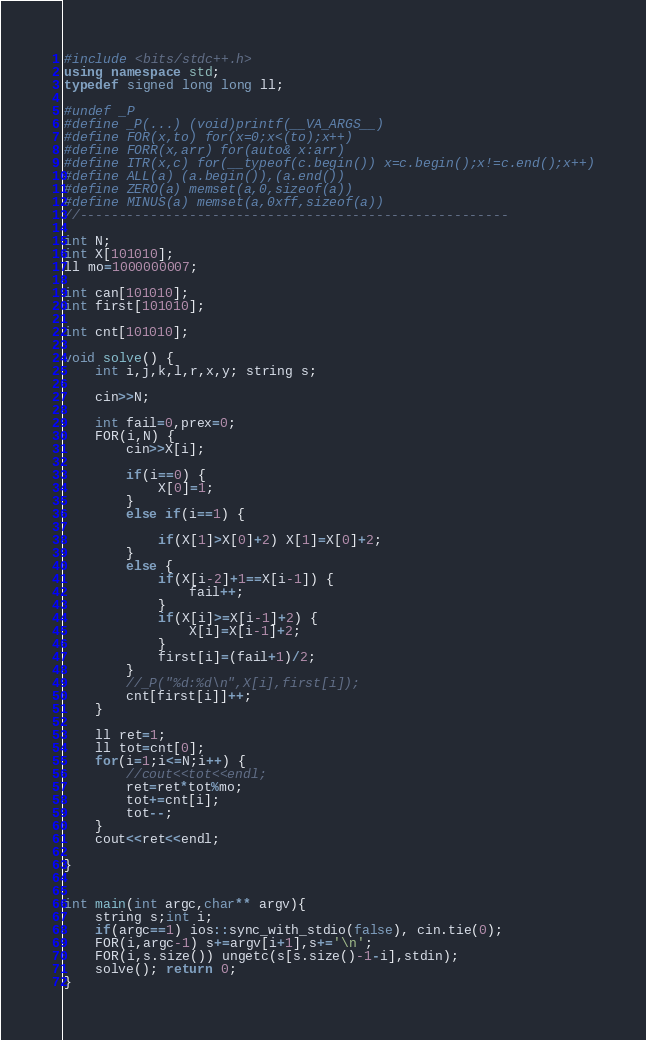<code> <loc_0><loc_0><loc_500><loc_500><_C++_>#include <bits/stdc++.h>
using namespace std;
typedef signed long long ll;

#undef _P
#define _P(...) (void)printf(__VA_ARGS__)
#define FOR(x,to) for(x=0;x<(to);x++)
#define FORR(x,arr) for(auto& x:arr)
#define ITR(x,c) for(__typeof(c.begin()) x=c.begin();x!=c.end();x++)
#define ALL(a) (a.begin()),(a.end())
#define ZERO(a) memset(a,0,sizeof(a))
#define MINUS(a) memset(a,0xff,sizeof(a))
//-------------------------------------------------------

int N;
int X[101010];
ll mo=1000000007;

int can[101010];
int first[101010];

int cnt[101010];

void solve() {
	int i,j,k,l,r,x,y; string s;
	
	cin>>N;
	
	int fail=0,prex=0;
	FOR(i,N) {
		cin>>X[i];
		
		if(i==0) {
			X[0]=1;
		}
		else if(i==1) {
			
			if(X[1]>X[0]+2) X[1]=X[0]+2;
		}
		else {
			if(X[i-2]+1==X[i-1]) {
				fail++;
			}
			if(X[i]>=X[i-1]+2) {
				X[i]=X[i-1]+2;
			}
			first[i]=(fail+1)/2;
		}
		//_P("%d:%d\n",X[i],first[i]);
		cnt[first[i]]++;
	}
	
	ll ret=1;
	ll tot=cnt[0];
	for(i=1;i<=N;i++) {
		//cout<<tot<<endl;
		ret=ret*tot%mo;
		tot+=cnt[i];
		tot--;
	}
	cout<<ret<<endl;
	
}


int main(int argc,char** argv){
	string s;int i;
	if(argc==1) ios::sync_with_stdio(false), cin.tie(0);
	FOR(i,argc-1) s+=argv[i+1],s+='\n';
	FOR(i,s.size()) ungetc(s[s.size()-1-i],stdin);
	solve(); return 0;
}
</code> 